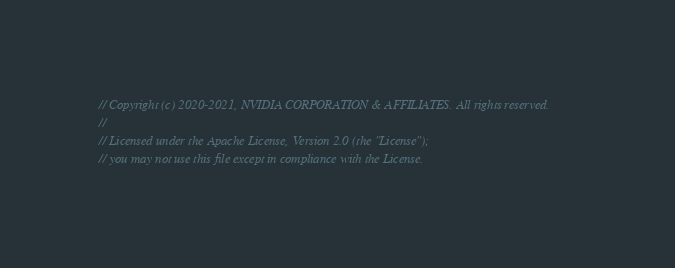Convert code to text. <code><loc_0><loc_0><loc_500><loc_500><_Cuda_>// Copyright (c) 2020-2021, NVIDIA CORPORATION & AFFILIATES. All rights reserved.
//
// Licensed under the Apache License, Version 2.0 (the "License");
// you may not use this file except in compliance with the License.</code> 